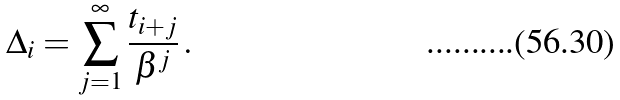Convert formula to latex. <formula><loc_0><loc_0><loc_500><loc_500>\Delta _ { i } = \sum _ { j = 1 } ^ { \infty } \frac { t _ { i + j } } { \beta ^ { j } } \, .</formula> 